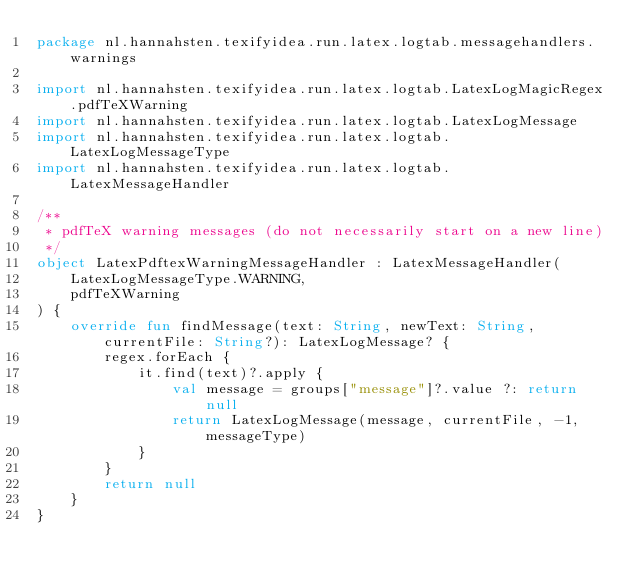Convert code to text. <code><loc_0><loc_0><loc_500><loc_500><_Kotlin_>package nl.hannahsten.texifyidea.run.latex.logtab.messagehandlers.warnings

import nl.hannahsten.texifyidea.run.latex.logtab.LatexLogMagicRegex.pdfTeXWarning
import nl.hannahsten.texifyidea.run.latex.logtab.LatexLogMessage
import nl.hannahsten.texifyidea.run.latex.logtab.LatexLogMessageType
import nl.hannahsten.texifyidea.run.latex.logtab.LatexMessageHandler

/**
 * pdfTeX warning messages (do not necessarily start on a new line)
 */
object LatexPdftexWarningMessageHandler : LatexMessageHandler(
    LatexLogMessageType.WARNING,
    pdfTeXWarning
) {
    override fun findMessage(text: String, newText: String, currentFile: String?): LatexLogMessage? {
        regex.forEach {
            it.find(text)?.apply {
                val message = groups["message"]?.value ?: return null
                return LatexLogMessage(message, currentFile, -1, messageType)
            }
        }
        return null
    }
}</code> 